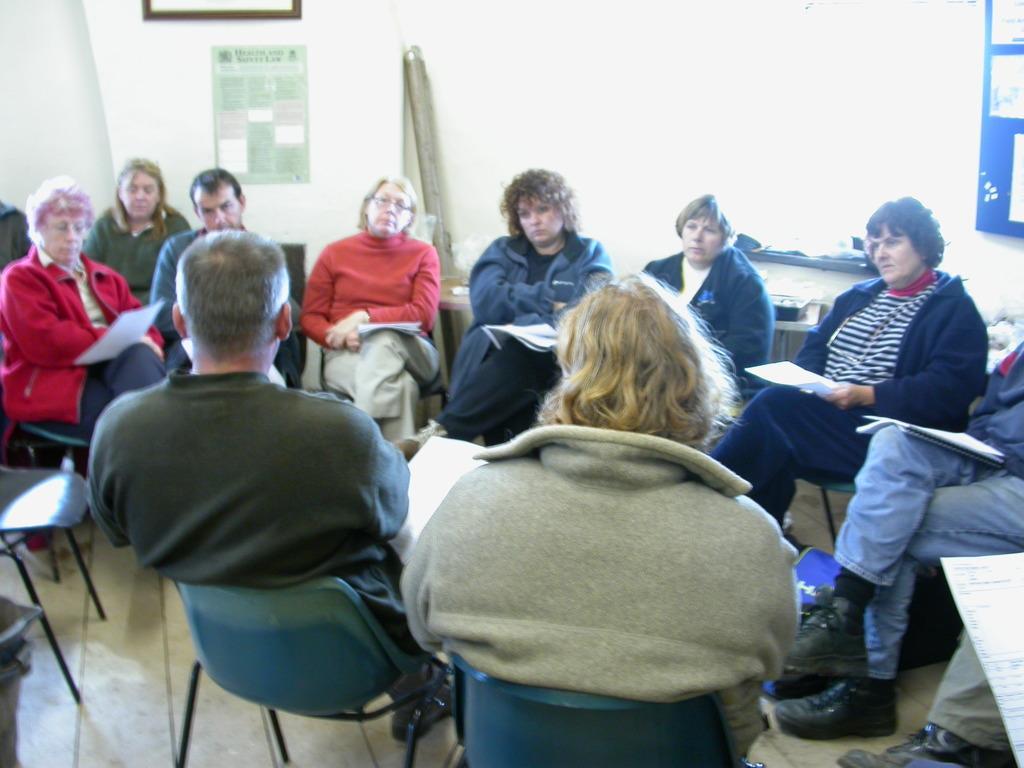Please provide a concise description of this image. In the image there were group of people sitting in a circle in a room. In the center there were two people facing backward and the remaining are facing front. All of them are holding a papers. In the top right there is a board with the papers and in the background there is a chart and one frame. 